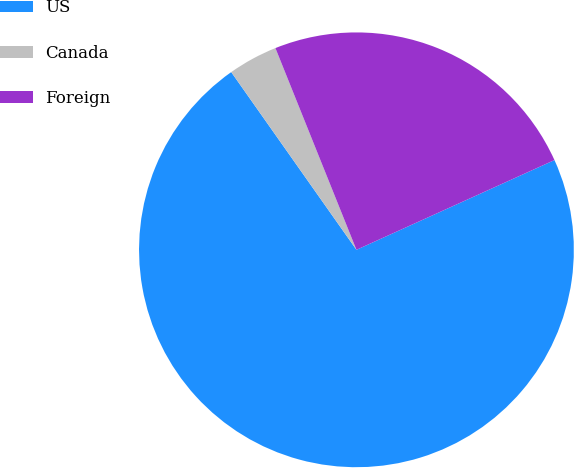Convert chart to OTSL. <chart><loc_0><loc_0><loc_500><loc_500><pie_chart><fcel>US<fcel>Canada<fcel>Foreign<nl><fcel>72.01%<fcel>3.69%<fcel>24.31%<nl></chart> 